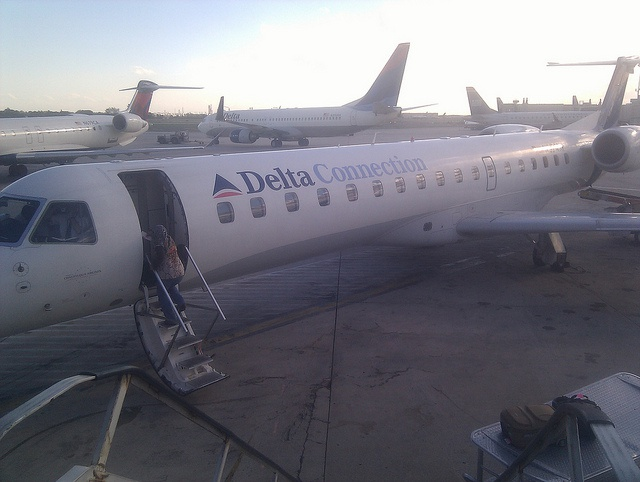Describe the objects in this image and their specific colors. I can see airplane in lavender, gray, darkgray, and black tones, airplane in lavender, darkgray, gray, and white tones, airplane in lavender, darkgray, gray, and lightgray tones, people in lavender, black, and gray tones, and airplane in lavender, darkgray, and gray tones in this image. 